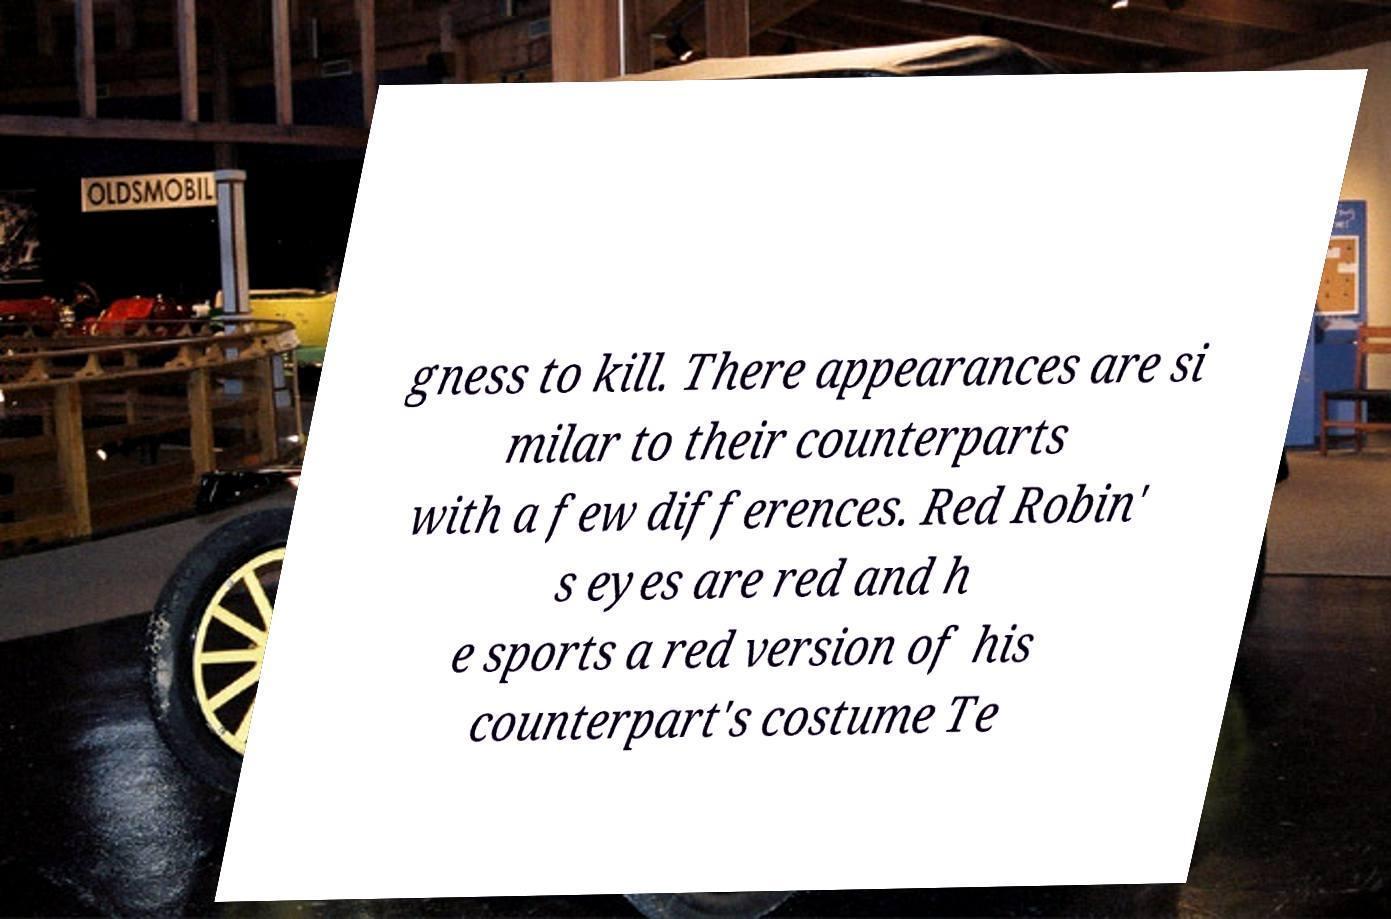Could you extract and type out the text from this image? gness to kill. There appearances are si milar to their counterparts with a few differences. Red Robin' s eyes are red and h e sports a red version of his counterpart's costume Te 